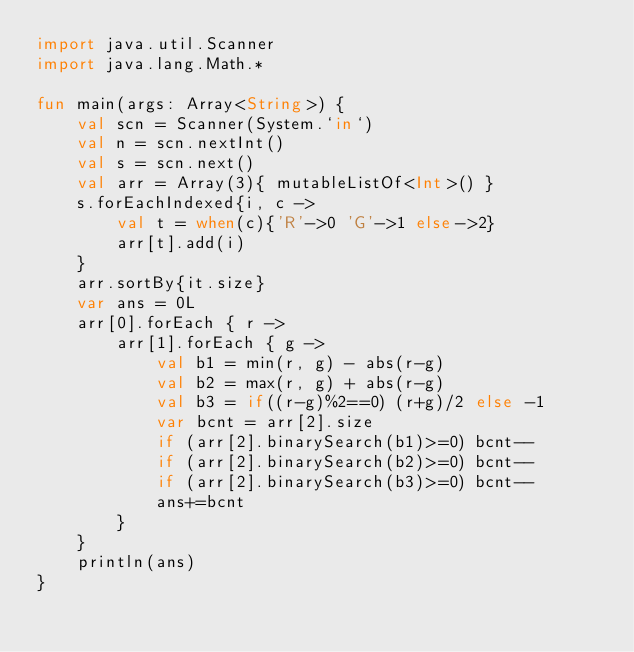<code> <loc_0><loc_0><loc_500><loc_500><_Kotlin_>import java.util.Scanner
import java.lang.Math.*

fun main(args: Array<String>) {
	val scn = Scanner(System.`in`)
	val n = scn.nextInt()
	val s = scn.next()
	val arr = Array(3){ mutableListOf<Int>() }
	s.forEachIndexed{i, c ->
		val t = when(c){'R'->0 'G'->1 else->2}
		arr[t].add(i)
	}
	arr.sortBy{it.size}
	var ans = 0L
	arr[0].forEach { r ->
		arr[1].forEach { g ->
			val b1 = min(r, g) - abs(r-g)
			val b2 = max(r, g) + abs(r-g)
			val b3 = if((r-g)%2==0) (r+g)/2 else -1
			var bcnt = arr[2].size
			if (arr[2].binarySearch(b1)>=0) bcnt--
			if (arr[2].binarySearch(b2)>=0) bcnt--
			if (arr[2].binarySearch(b3)>=0) bcnt--
			ans+=bcnt
		}
	}
	println(ans)
}</code> 